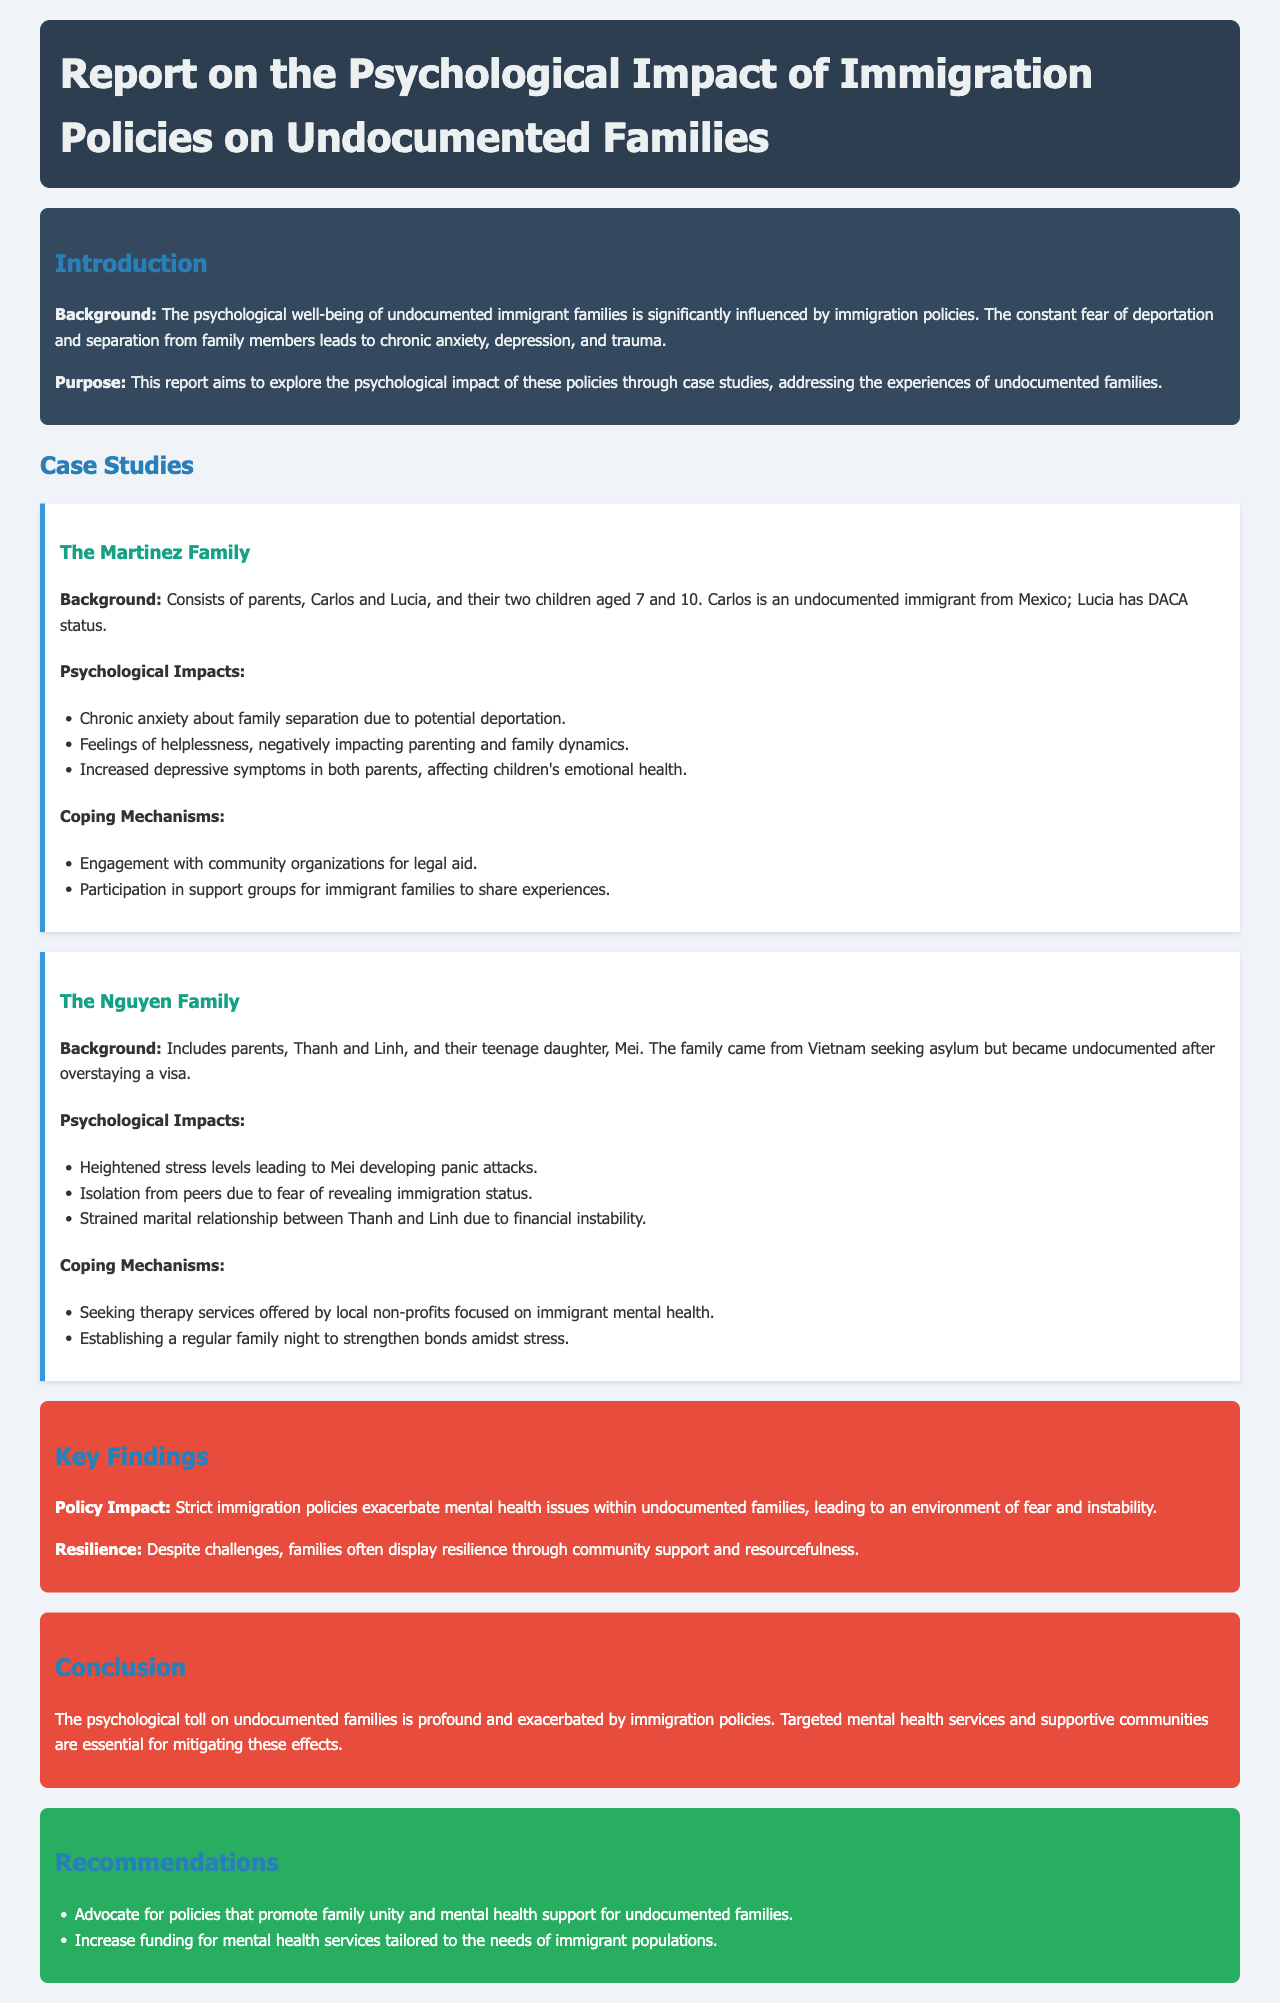What is the primary focus of the report? The report primarily focuses on the psychological impact of immigration policies on undocumented families.
Answer: Psychosocial impact How many children are in the Martinez family? The document states that the Martinez family has two children.
Answer: Two What coping mechanism does the Nguyen family utilize to strengthen bonds? The Nguyen family established a regular family night as a coping mechanism.
Answer: Family night What aspect of health do immigration policies negatively affect according to the findings? The key findings highlight that immigration policies exacerbate mental health issues within undocumented families.
Answer: Mental health How does the report suggest policymakers support undocumented families? It recommends advocating for policies that promote family unity and mental health support.
Answer: Policy advocacy What is the nationality of Carlos from the Martinez family? Carlos is identified as an undocumented immigrant from Mexico.
Answer: Mexico What kind of therapy does the Nguyen family seek? The Nguyen family seeks therapy services offered by local non-profits focused on immigrant mental health.
Answer: Therapy services How does the report describe the resilience of families facing immigration challenges? Families often display resilience through community support and resourcefulness, despite challenges.
Answer: Community support What type of document is this report? The document is a report detailing the psychological impact of immigration policies.
Answer: Report 